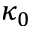Convert formula to latex. <formula><loc_0><loc_0><loc_500><loc_500>\kappa _ { 0 }</formula> 